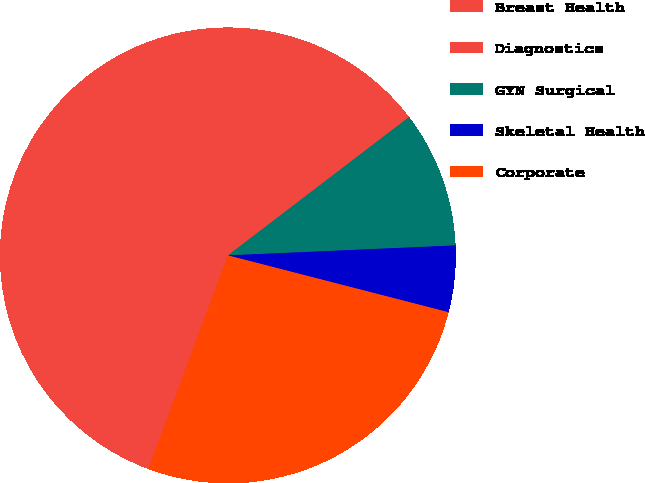Convert chart. <chart><loc_0><loc_0><loc_500><loc_500><pie_chart><fcel>Breast Health<fcel>Diagnostics<fcel>GYN Surgical<fcel>Skeletal Health<fcel>Corporate<nl><fcel>37.7%<fcel>21.24%<fcel>9.68%<fcel>4.71%<fcel>26.66%<nl></chart> 